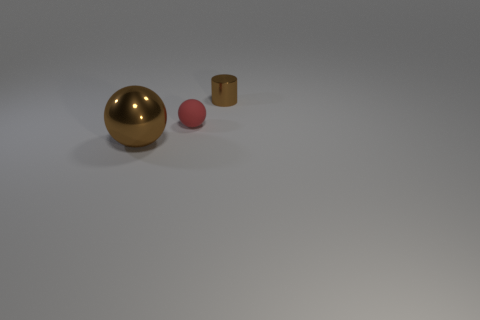Subtract 1 balls. How many balls are left? 1 Add 2 small red spheres. How many small red spheres exist? 3 Add 1 small rubber objects. How many objects exist? 4 Subtract 1 brown cylinders. How many objects are left? 2 Subtract all balls. How many objects are left? 1 Subtract all red balls. Subtract all blue cylinders. How many balls are left? 1 Subtract all yellow cylinders. How many red spheres are left? 1 Subtract all tiny rubber objects. Subtract all tiny cyan metal blocks. How many objects are left? 2 Add 2 brown metal cylinders. How many brown metal cylinders are left? 3 